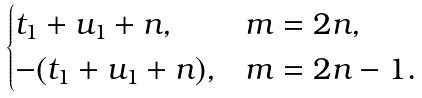<formula> <loc_0><loc_0><loc_500><loc_500>\begin{cases} t _ { 1 } + u _ { 1 } + n , & m = 2 n , \\ - ( t _ { 1 } + u _ { 1 } + n ) , & m = 2 n - 1 . \end{cases}</formula> 